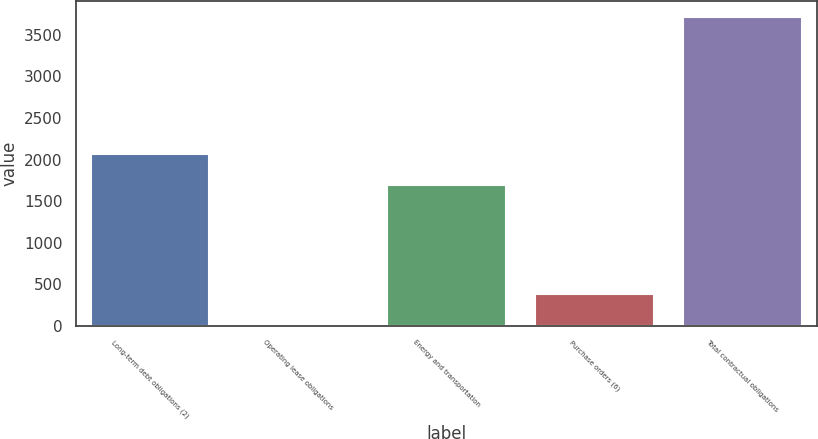Convert chart to OTSL. <chart><loc_0><loc_0><loc_500><loc_500><bar_chart><fcel>Long-term debt obligations (2)<fcel>Operating lease obligations<fcel>Energy and transportation<fcel>Purchase orders (6)<fcel>Total contractual obligations<nl><fcel>2061.2<fcel>16.8<fcel>1691.4<fcel>386.6<fcel>3714.8<nl></chart> 